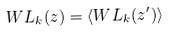Convert formula to latex. <formula><loc_0><loc_0><loc_500><loc_500>W L _ { k } ( z ) = \langle W L _ { k } ( z ^ { \prime } ) \rangle</formula> 